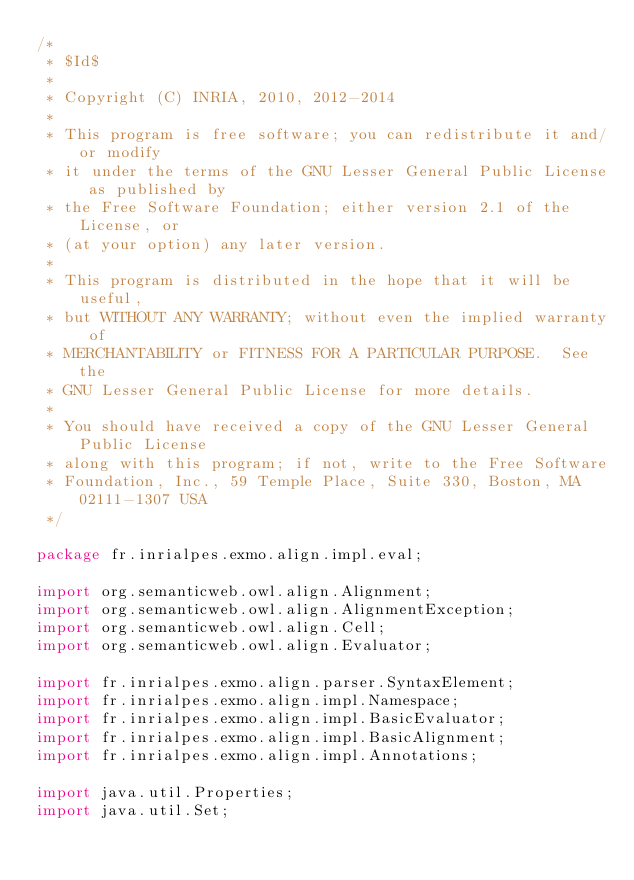<code> <loc_0><loc_0><loc_500><loc_500><_Java_>/*
 * $Id$
 *
 * Copyright (C) INRIA, 2010, 2012-2014
 *
 * This program is free software; you can redistribute it and/or modify
 * it under the terms of the GNU Lesser General Public License as published by
 * the Free Software Foundation; either version 2.1 of the License, or
 * (at your option) any later version.
 * 
 * This program is distributed in the hope that it will be useful,
 * but WITHOUT ANY WARRANTY; without even the implied warranty of
 * MERCHANTABILITY or FITNESS FOR A PARTICULAR PURPOSE.  See the
 * GNU Lesser General Public License for more details.
 * 
 * You should have received a copy of the GNU Lesser General Public License
 * along with this program; if not, write to the Free Software
 * Foundation, Inc., 59 Temple Place, Suite 330, Boston, MA  02111-1307 USA
 */

package fr.inrialpes.exmo.align.impl.eval;

import org.semanticweb.owl.align.Alignment;
import org.semanticweb.owl.align.AlignmentException;
import org.semanticweb.owl.align.Cell;
import org.semanticweb.owl.align.Evaluator;

import fr.inrialpes.exmo.align.parser.SyntaxElement;
import fr.inrialpes.exmo.align.impl.Namespace;
import fr.inrialpes.exmo.align.impl.BasicEvaluator;
import fr.inrialpes.exmo.align.impl.BasicAlignment;
import fr.inrialpes.exmo.align.impl.Annotations;

import java.util.Properties;
import java.util.Set;</code> 